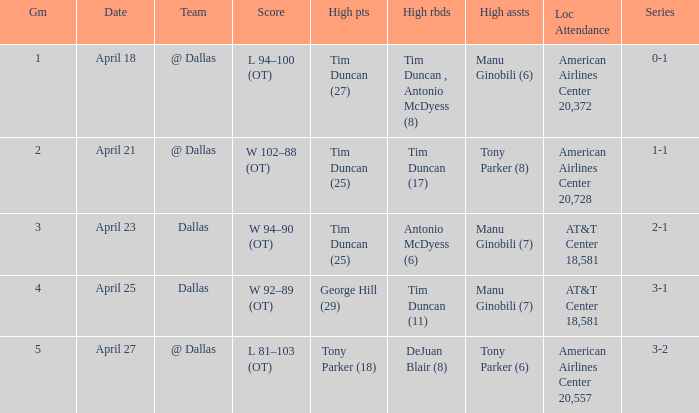When george hill (29) has the highest amount of points what is the date? April 25. 